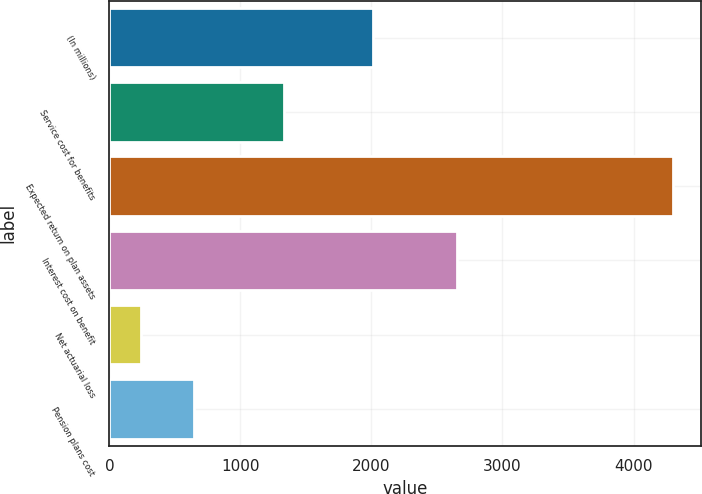Convert chart to OTSL. <chart><loc_0><loc_0><loc_500><loc_500><bar_chart><fcel>(In millions)<fcel>Service cost for benefits<fcel>Expected return on plan assets<fcel>Interest cost on benefit<fcel>Net actuarial loss<fcel>Pension plans cost<nl><fcel>2008<fcel>1331<fcel>4298<fcel>2653<fcel>237<fcel>643.1<nl></chart> 